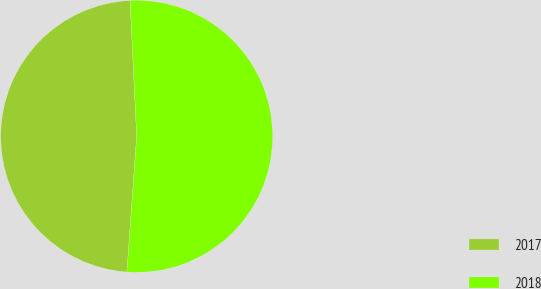Convert chart to OTSL. <chart><loc_0><loc_0><loc_500><loc_500><pie_chart><fcel>2017<fcel>2018<nl><fcel>48.08%<fcel>51.92%<nl></chart> 